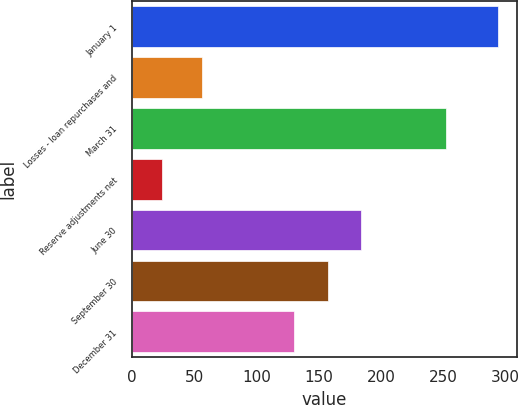<chart> <loc_0><loc_0><loc_500><loc_500><bar_chart><fcel>January 1<fcel>Losses - loan repurchases and<fcel>March 31<fcel>Reserve adjustments net<fcel>June 30<fcel>September 30<fcel>December 31<nl><fcel>294<fcel>56<fcel>252<fcel>24<fcel>184<fcel>157<fcel>130<nl></chart> 